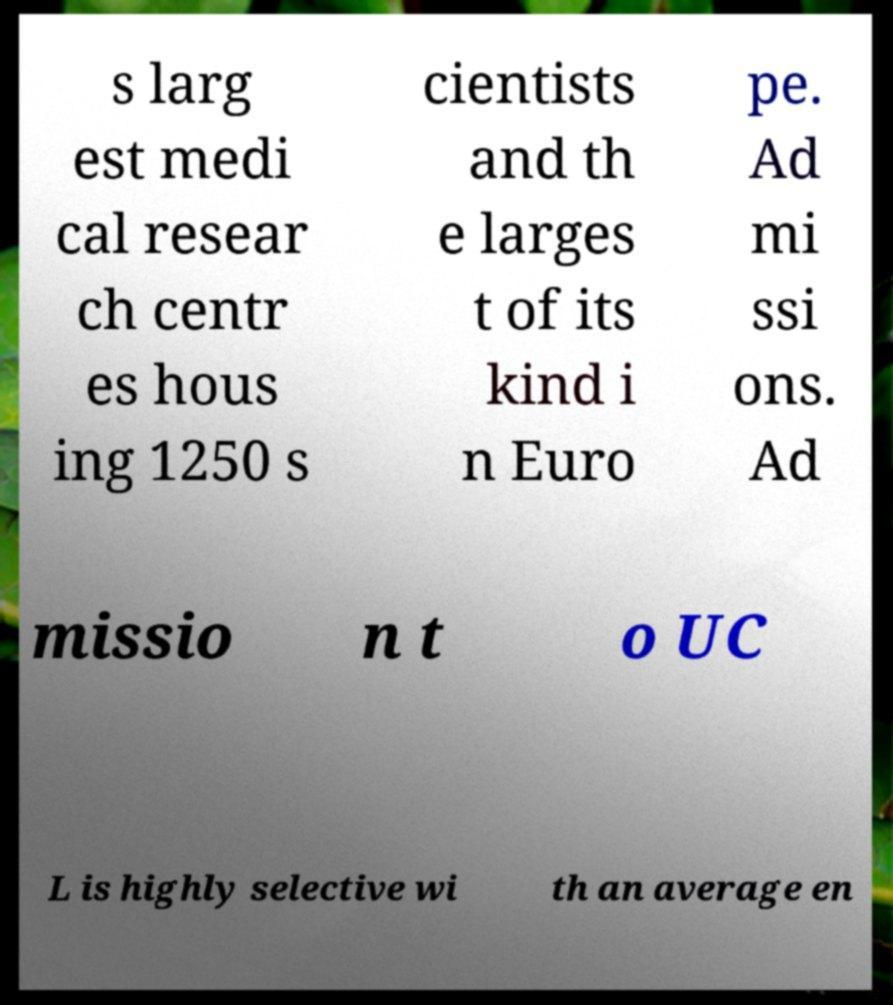There's text embedded in this image that I need extracted. Can you transcribe it verbatim? s larg est medi cal resear ch centr es hous ing 1250 s cientists and th e larges t of its kind i n Euro pe. Ad mi ssi ons. Ad missio n t o UC L is highly selective wi th an average en 